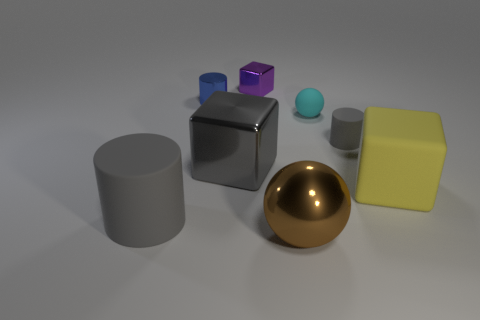Is the number of gray rubber objects that are to the right of the cyan rubber thing less than the number of blue rubber objects?
Provide a short and direct response. No. Is there any other thing that has the same shape as the blue shiny thing?
Keep it short and to the point. Yes. Are there any small matte cylinders?
Give a very brief answer. Yes. Is the number of small cylinders less than the number of tiny gray matte blocks?
Give a very brief answer. No. What number of small brown objects have the same material as the large yellow object?
Provide a succinct answer. 0. What color is the other block that is made of the same material as the gray cube?
Your answer should be compact. Purple. There is a tiny blue metallic object; what shape is it?
Ensure brevity in your answer.  Cylinder. How many other balls have the same color as the shiny sphere?
Offer a very short reply. 0. There is a gray matte object that is the same size as the cyan matte thing; what shape is it?
Your response must be concise. Cylinder. Are there any yellow matte things that have the same size as the brown metallic object?
Your answer should be compact. Yes. 